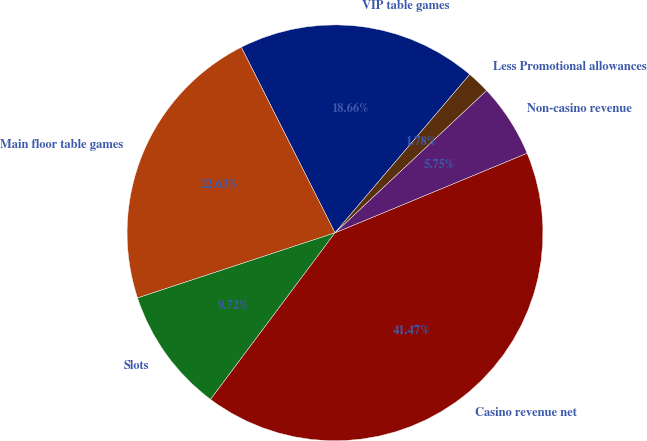Convert chart to OTSL. <chart><loc_0><loc_0><loc_500><loc_500><pie_chart><fcel>VIP table games<fcel>Main floor table games<fcel>Slots<fcel>Casino revenue net<fcel>Non-casino revenue<fcel>Less Promotional allowances<nl><fcel>18.66%<fcel>22.63%<fcel>9.72%<fcel>41.47%<fcel>5.75%<fcel>1.78%<nl></chart> 